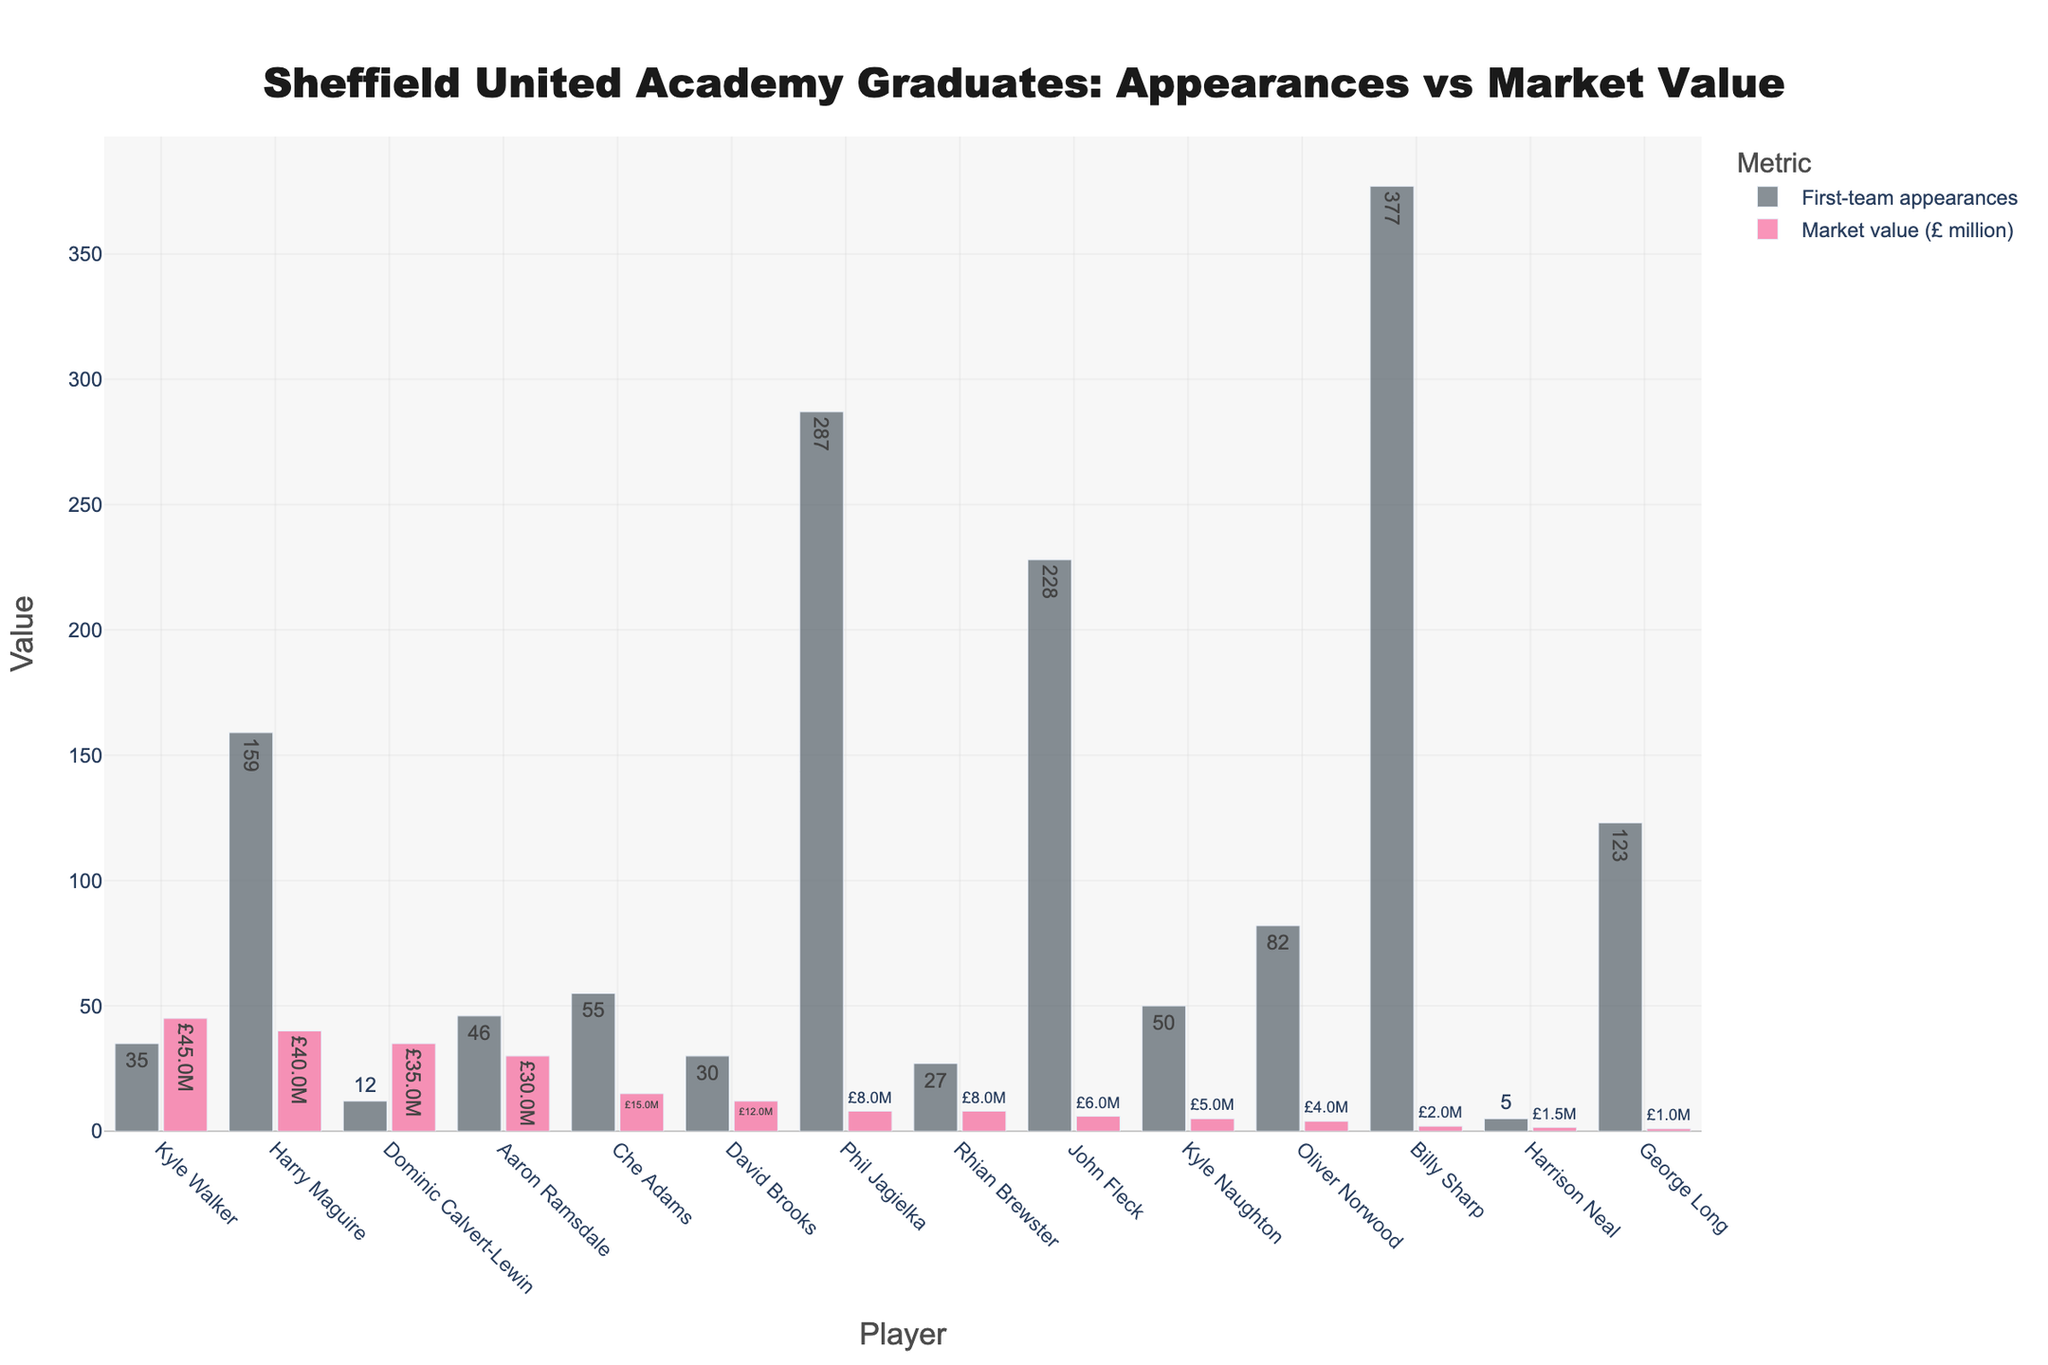Which player has the highest market value? When observing the bar heights for the market value in the "Sheffield United Academy Graduates: Appearances vs Market Value" figure, Kyle Walker's bar is the tallest.
Answer: Kyle Walker Which player made the most first-team appearances? From the bar chart, the longest bar in the "First-team appearances" category belongs to Billy Sharp.
Answer: Billy Sharp Who has a higher market value: Dominic Calvert-Lewin or Aaron Ramsdale? By comparing the bar heights in the market value category for both players, Dominic Calvert-Lewin's bar is taller than Aaron Ramsdale's.
Answer: Dominic Calvert-Lewin What are the combined first-team appearances for Harry Maguire and Phil Jagielka? From the chart, Harry Maguire has 159 first-team appearances and Phil Jagielka has 287. Adding them together, 159 + 287 = 446.
Answer: 446 How does David Brooks’ market value compare to Che Adams’? David Brooks has a shorter bar in the market value category than Che Adams. Therefore, David Brooks has a lower market value.
Answer: Lower Which player appears to be undervalued based on the number of first-team appearances vs. market value? Observing the players, Phil Jagielka stands out with significantly high first-team appearances (287) but a relatively low market value (£8M).
Answer: Phil Jagielka Who has the highest market value among those with less than 50 first-team appearances? Analyzing the chart for players with less than 50 first-team appearances, Dominic Calvert-Lewin, with a market value of £35M, stands out.
Answer: Dominic Calvert-Lewin What’s the total market value of the top three players by market value? The top three players by market value are Kyle Walker (£45M), Dominic Calvert-Lewin (£35M), and Harry Maguire (£40M). Adding them together gives 45 + 35 + 40 = £120M.
Answer: £120M How many players have a market value greater than £10 million? Counting the bars in the market value category that surpass the £10M mark, the players are Harry Maguire, Kyle Walker, Dominic Calvert-Lewin, David Brooks, Aaron Ramsdale, and Che Adams, totaling 6.
Answer: 6 Compare the first-team appearances of the least and most valuable players. What’s the difference? The most valuable player is Kyle Walker (£45M), with 35 first-team appearances. The least valuable is George Long (£1M), with 123 appearances. The difference is 123 - 35 = 88.
Answer: 88 